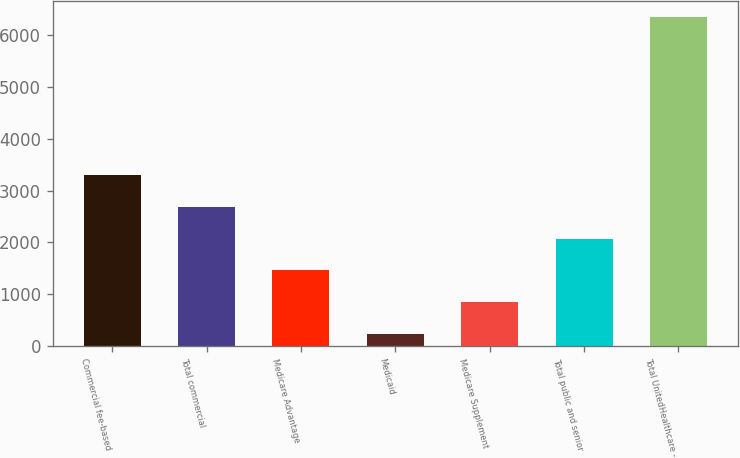Convert chart. <chart><loc_0><loc_0><loc_500><loc_500><bar_chart><fcel>Commercial fee-based<fcel>Total commercial<fcel>Medicare Advantage<fcel>Medicaid<fcel>Medicare Supplement<fcel>Total public and senior<fcel>Total UnitedHealthcare -<nl><fcel>3292.5<fcel>2680<fcel>1455<fcel>230<fcel>842.5<fcel>2067.5<fcel>6355<nl></chart> 